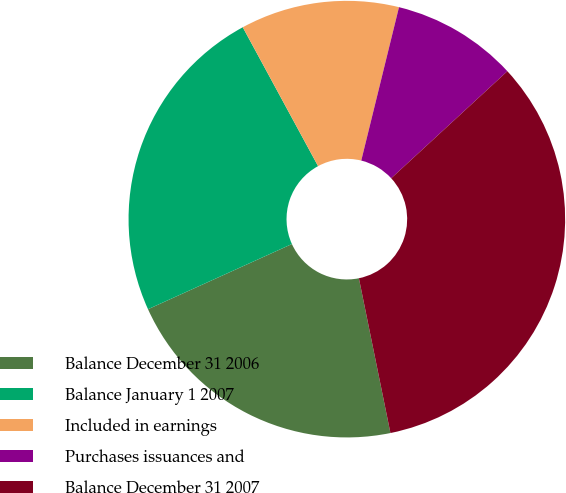Convert chart. <chart><loc_0><loc_0><loc_500><loc_500><pie_chart><fcel>Balance December 31 2006<fcel>Balance January 1 2007<fcel>Included in earnings<fcel>Purchases issuances and<fcel>Balance December 31 2007<nl><fcel>21.43%<fcel>23.86%<fcel>11.75%<fcel>9.31%<fcel>33.65%<nl></chart> 